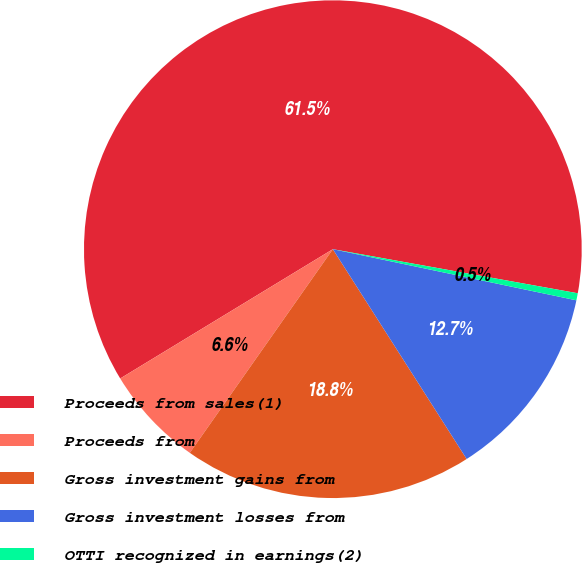<chart> <loc_0><loc_0><loc_500><loc_500><pie_chart><fcel>Proceeds from sales(1)<fcel>Proceeds from<fcel>Gross investment gains from<fcel>Gross investment losses from<fcel>OTTI recognized in earnings(2)<nl><fcel>61.53%<fcel>6.56%<fcel>18.78%<fcel>12.67%<fcel>0.46%<nl></chart> 